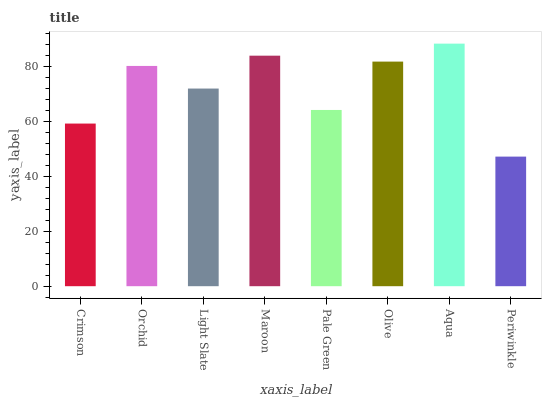Is Periwinkle the minimum?
Answer yes or no. Yes. Is Aqua the maximum?
Answer yes or no. Yes. Is Orchid the minimum?
Answer yes or no. No. Is Orchid the maximum?
Answer yes or no. No. Is Orchid greater than Crimson?
Answer yes or no. Yes. Is Crimson less than Orchid?
Answer yes or no. Yes. Is Crimson greater than Orchid?
Answer yes or no. No. Is Orchid less than Crimson?
Answer yes or no. No. Is Orchid the high median?
Answer yes or no. Yes. Is Light Slate the low median?
Answer yes or no. Yes. Is Periwinkle the high median?
Answer yes or no. No. Is Crimson the low median?
Answer yes or no. No. 